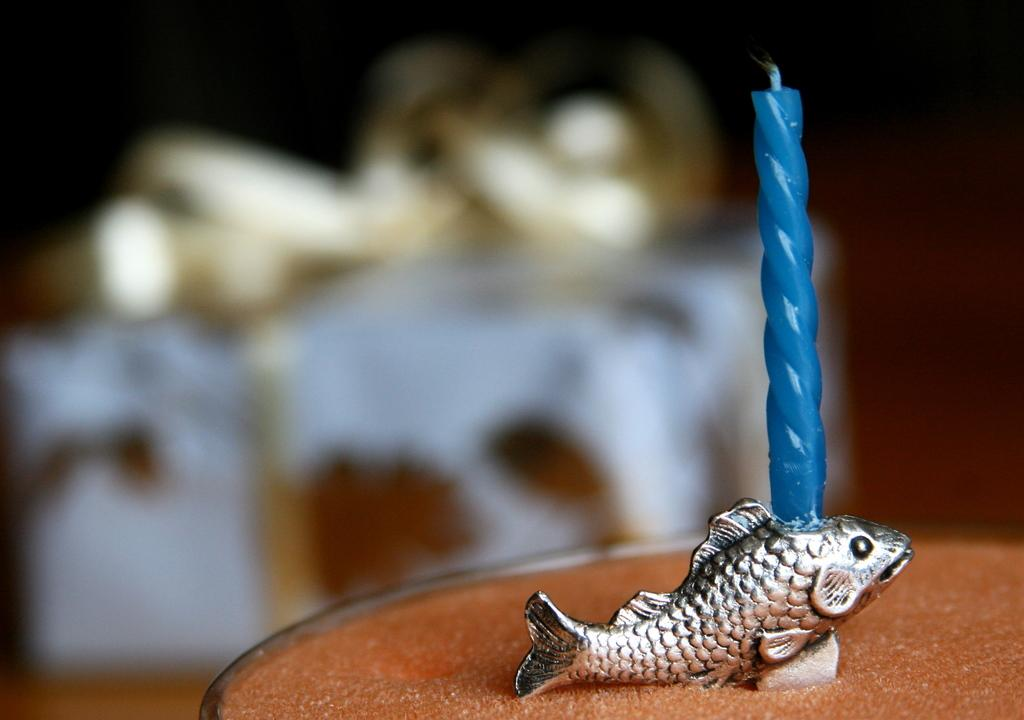What is the color of the object that the candle is placed on? The object is brown. What is the color of the candle? The candle is blue. What is the shape or subject of the sculpture near the candle? The sculpture is of a fish. Can you describe the background of the image? The background of the image is blurred. What type of discussion is taking place in the image? There is no discussion taking place in the image; it only features a brown object, a blue candle, a fish sculpture, and a blurred background. Can you see any waves in the image? There are no waves present in the image. 